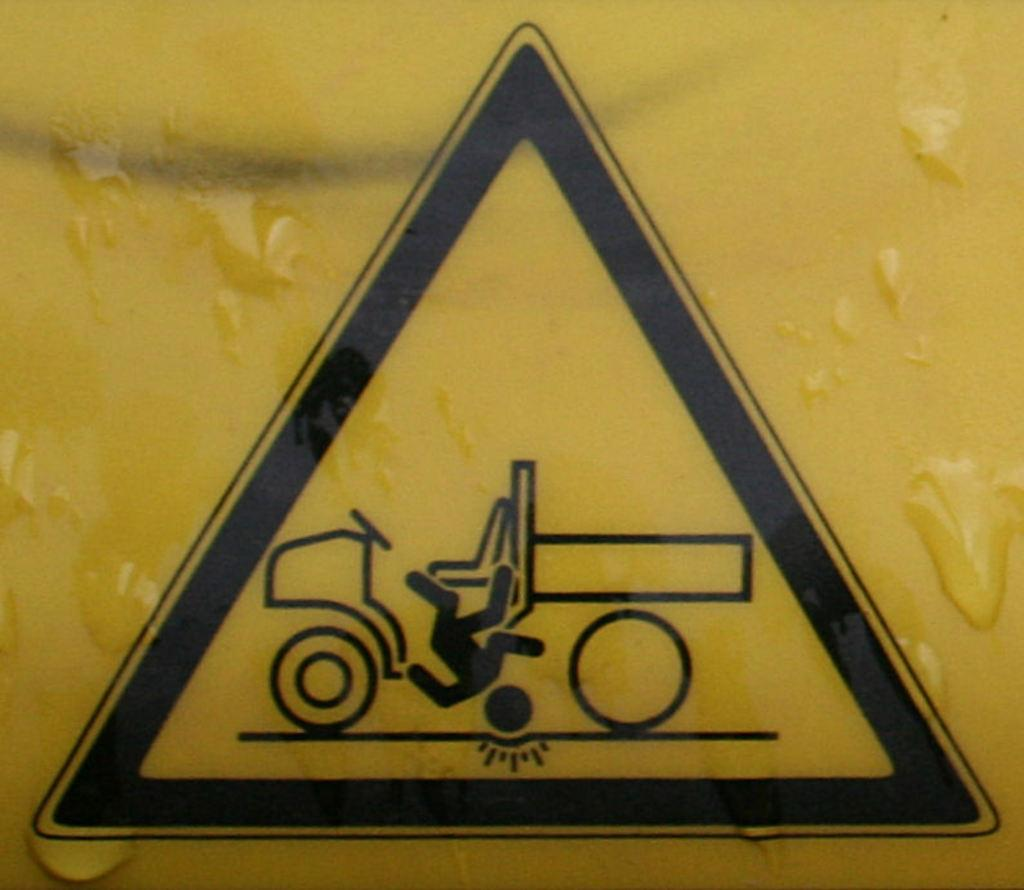What is the main object in the image? There is a yellow board in the image. What is depicted on the yellow board? There is a symbol on the yellow board. What is included in the symbol? The symbol contains a vehicle. What is happening to the person in the symbol? A person is falling from the vehicle in the symbol. What type of tool is the carpenter using to teach the wren in the image? There is no carpenter, tool, or wren present in the image. 